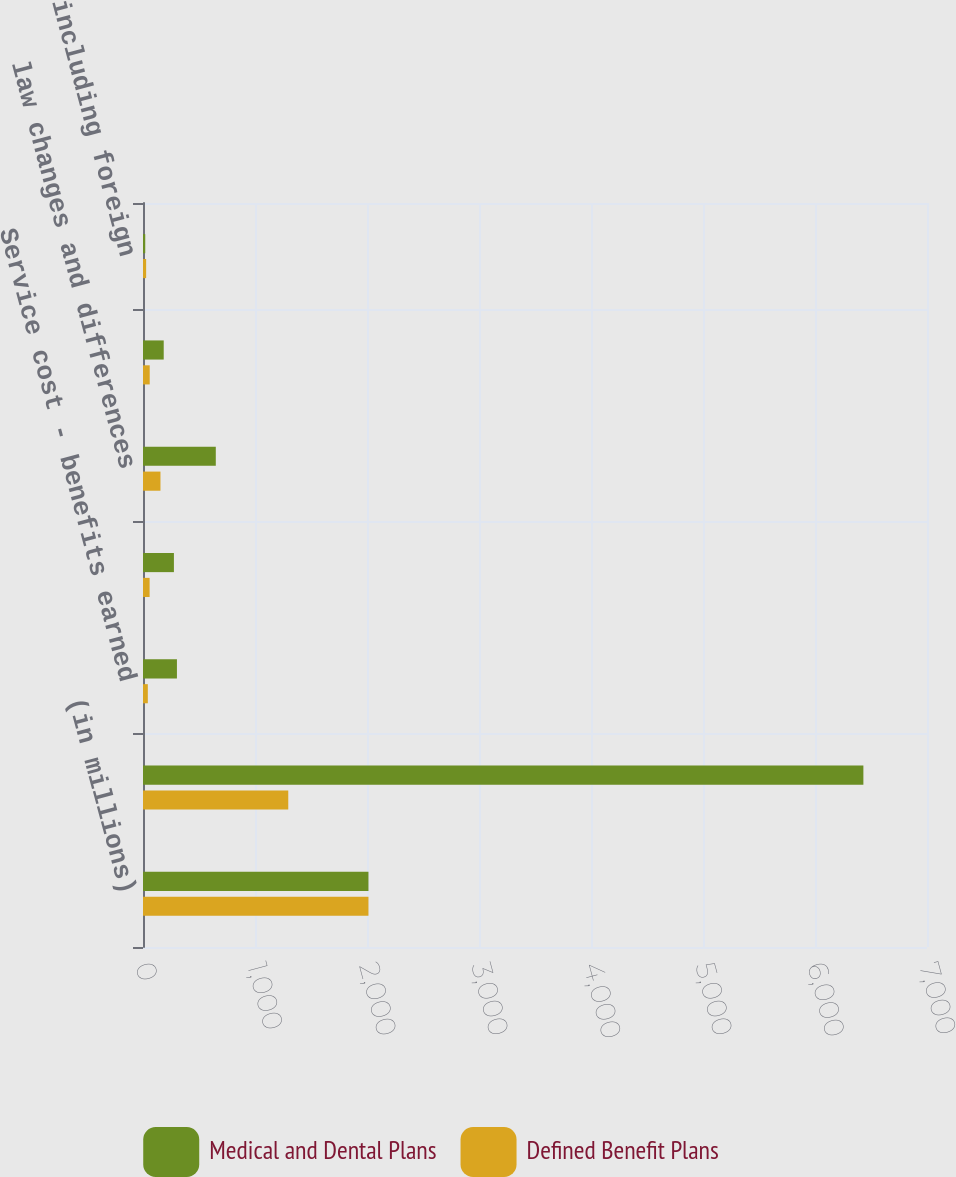<chart> <loc_0><loc_0><loc_500><loc_500><stacked_bar_chart><ecel><fcel>(in millions)<fcel>Projected benefit obligations<fcel>Service cost - benefits earned<fcel>Interest cost on projected<fcel>law changes and differences<fcel>Benefits paid<fcel>Other including foreign<nl><fcel>Medical and Dental Plans<fcel>2013<fcel>6432<fcel>303<fcel>276<fcel>650<fcel>185<fcel>20<nl><fcel>Defined Benefit Plans<fcel>2013<fcel>1297<fcel>43<fcel>59<fcel>156<fcel>60<fcel>28<nl></chart> 